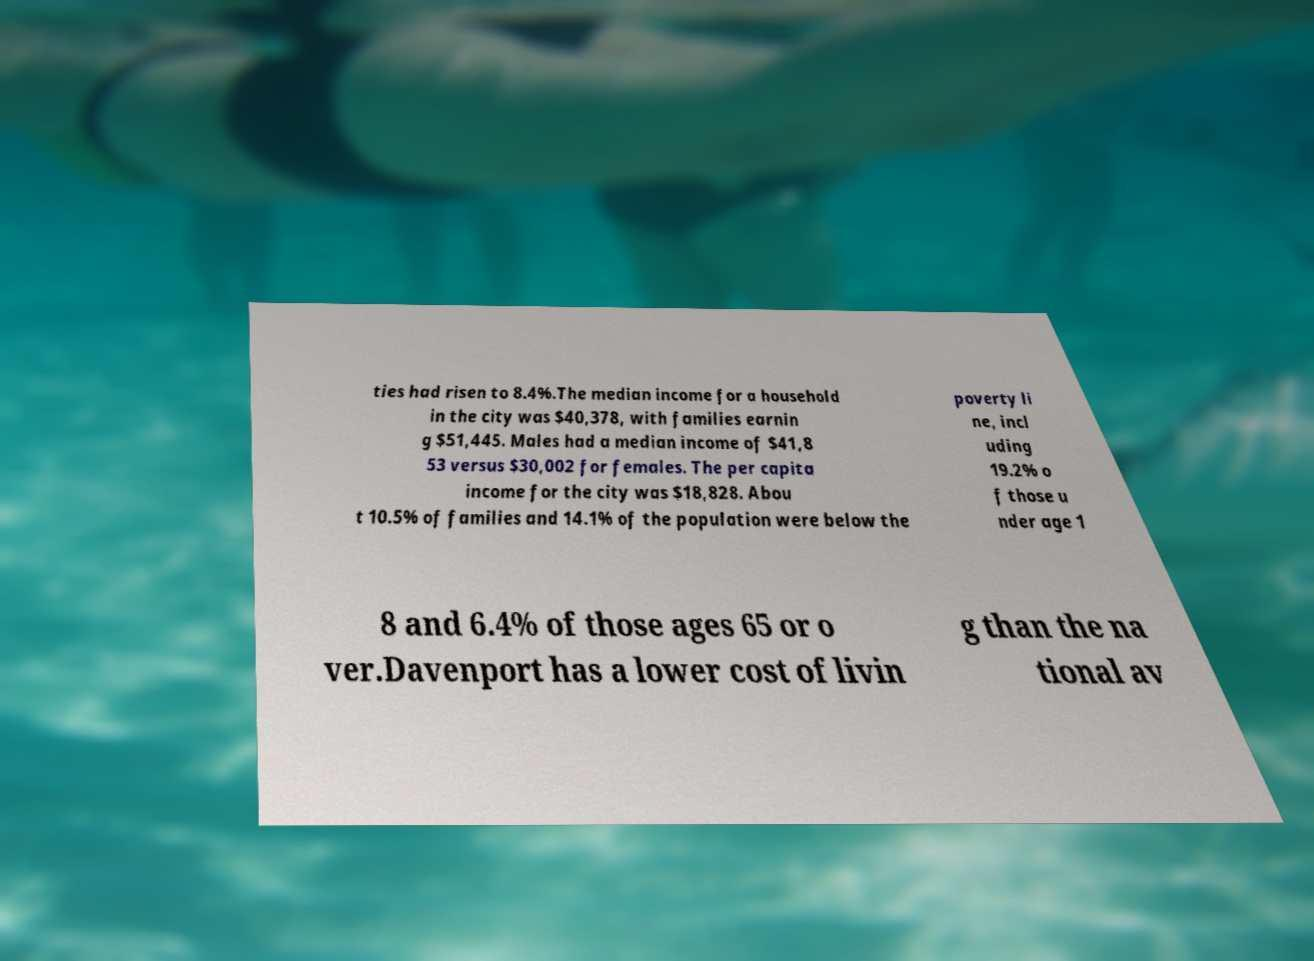Could you extract and type out the text from this image? ties had risen to 8.4%.The median income for a household in the city was $40,378, with families earnin g $51,445. Males had a median income of $41,8 53 versus $30,002 for females. The per capita income for the city was $18,828. Abou t 10.5% of families and 14.1% of the population were below the poverty li ne, incl uding 19.2% o f those u nder age 1 8 and 6.4% of those ages 65 or o ver.Davenport has a lower cost of livin g than the na tional av 